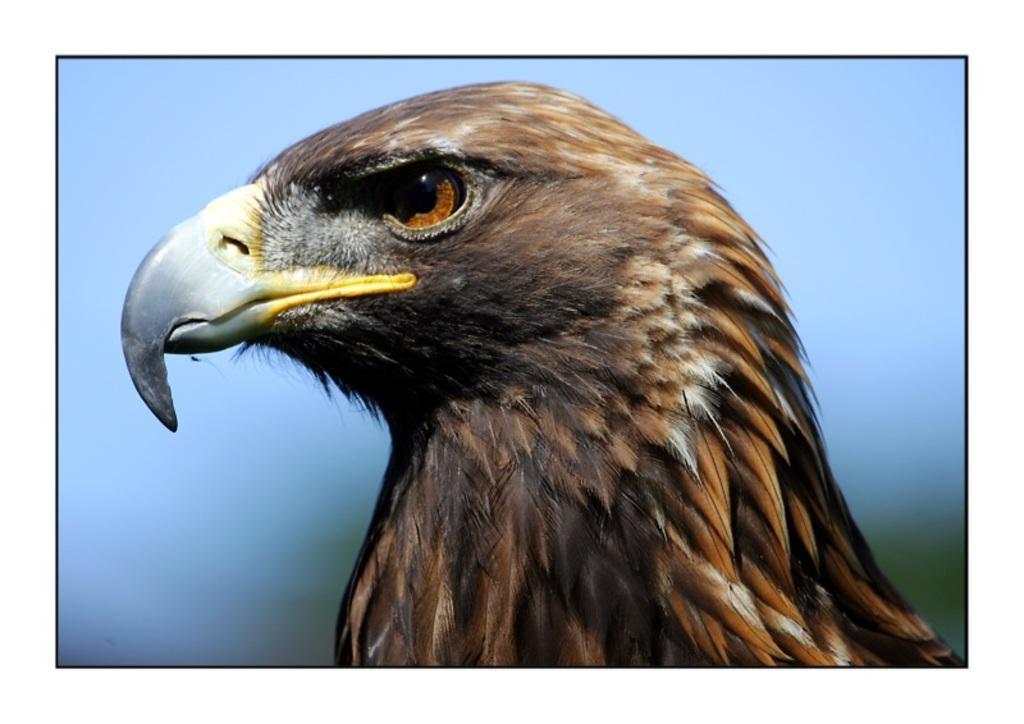Can you describe this image briefly? It is an edited image. I can see the face of an eagle. The background looks blurry. 